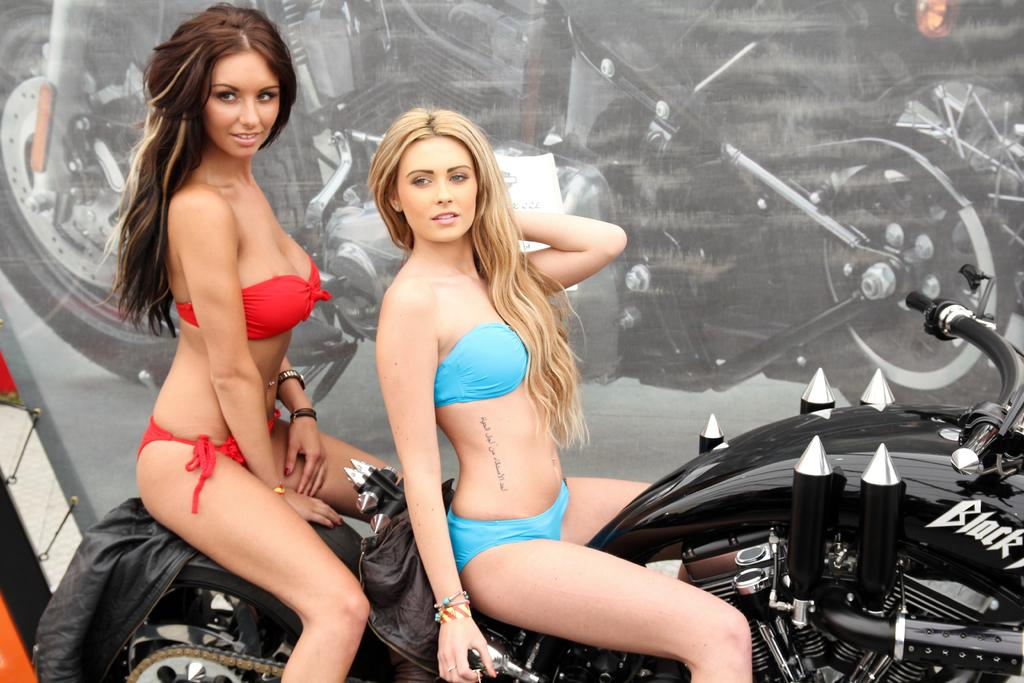How many people are in the image? There are 2 girls in the image. What are the girls doing in the image? The girls are sitting on a bike. What is the facial expression of the girls in the image? Both girls are smiling. What type of eggs can be seen in the image? There are no eggs present in the image; it features 2 girls sitting on a bike. What is the girls' wish while sitting on the bike in the image? There is no information about the girls' wishes in the image, as it only shows them sitting on a bike and smiling. 